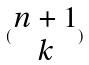<formula> <loc_0><loc_0><loc_500><loc_500>( \begin{matrix} n + 1 \\ k \end{matrix} )</formula> 